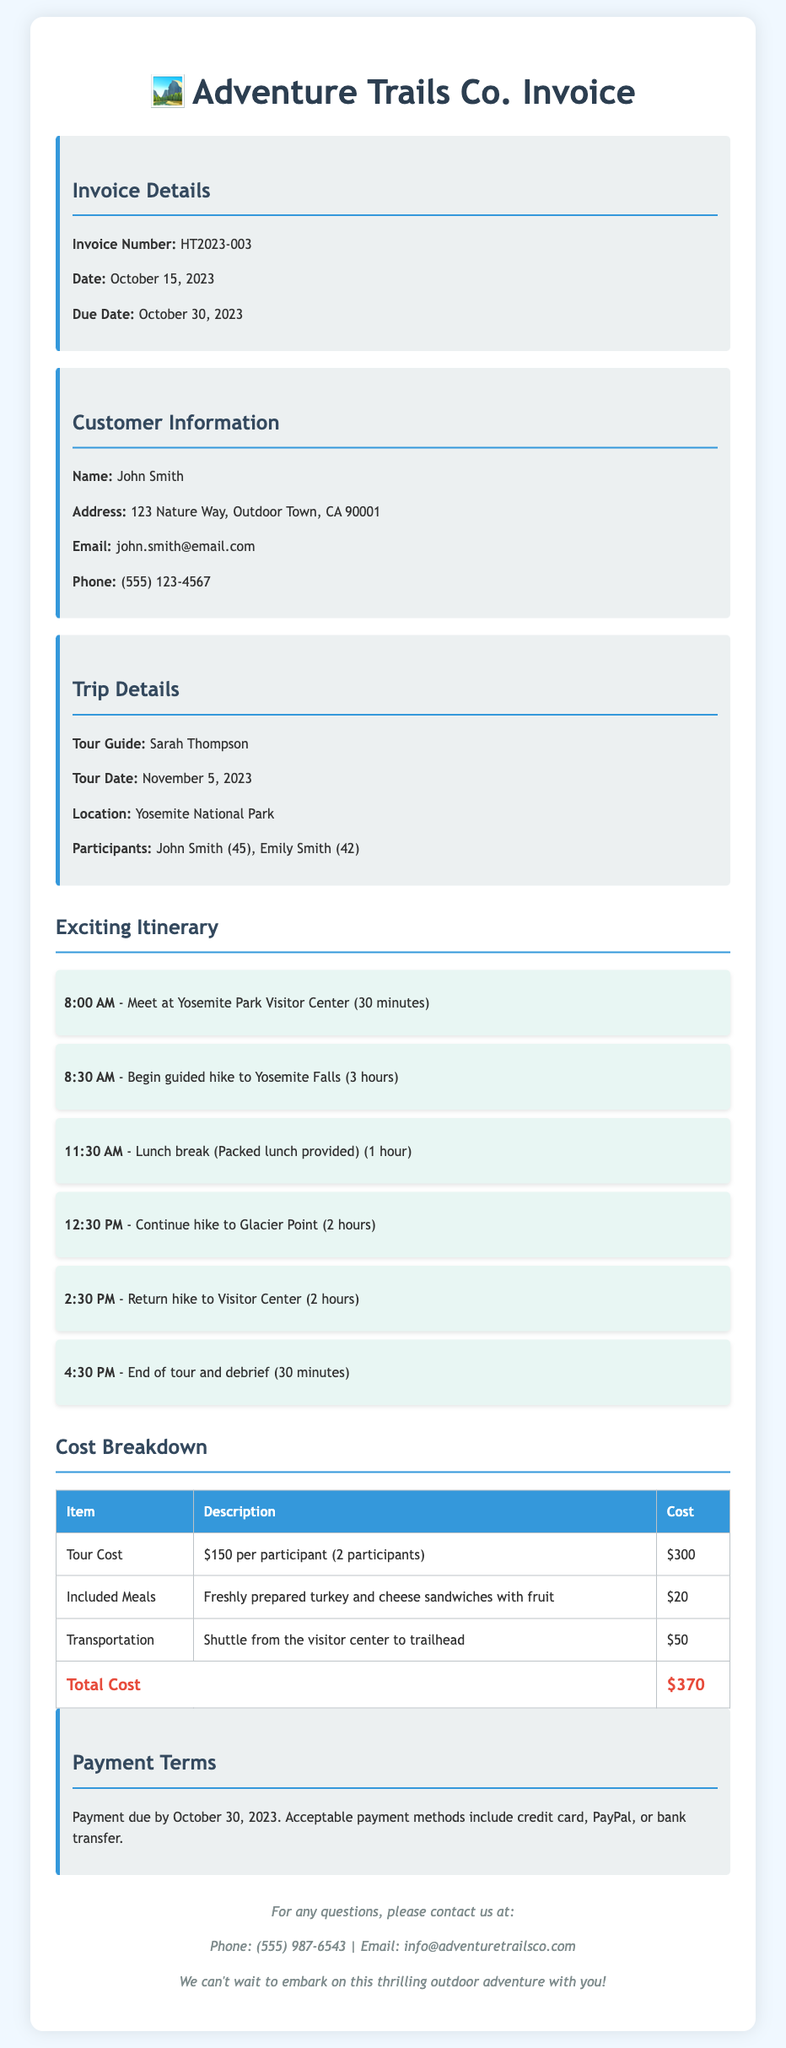What is the invoice number? The invoice number is a specific identifier for the transaction, listed as HT2023-003.
Answer: HT2023-003 Who is the tour guide? The tour guide's name is provided in the document under trip details as Sarah Thompson.
Answer: Sarah Thompson What date is the tour scheduled for? The tour date is specified in the document as November 5, 2023.
Answer: November 5, 2023 How many participants are included in the guided tour? The document indicates the number of participants which is two: John Smith and Emily Smith.
Answer: 2 What is the total cost of the tour? The total cost is calculated based on the breakdown of expenses and is listed at the bottom of the cost table as $370.
Answer: $370 What does the included meal consist of? The description of the included meal details freshly prepared turkey and cheese sandwiches with fruit.
Answer: Turkey and cheese sandwiches with fruit When is payment due? The due date for payment is stated in the document as October 30, 2023.
Answer: October 30, 2023 What type of transportation is provided? The document mentions the transportation provided as a shuttle from the visitor center to trailhead.
Answer: Shuttle What is the duration of the lunch break? The duration of the lunch break is outlined in the itinerary as one hour.
Answer: 1 hour 